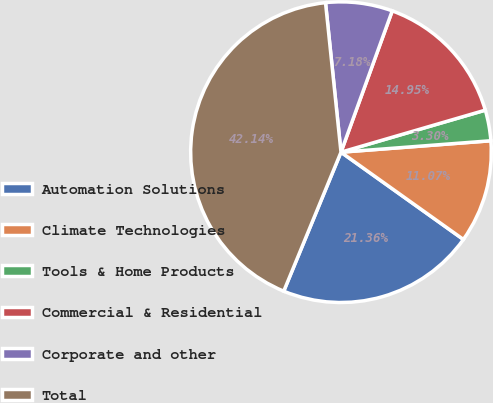<chart> <loc_0><loc_0><loc_500><loc_500><pie_chart><fcel>Automation Solutions<fcel>Climate Technologies<fcel>Tools & Home Products<fcel>Commercial & Residential<fcel>Corporate and other<fcel>Total<nl><fcel>21.36%<fcel>11.07%<fcel>3.3%<fcel>14.95%<fcel>7.18%<fcel>42.14%<nl></chart> 